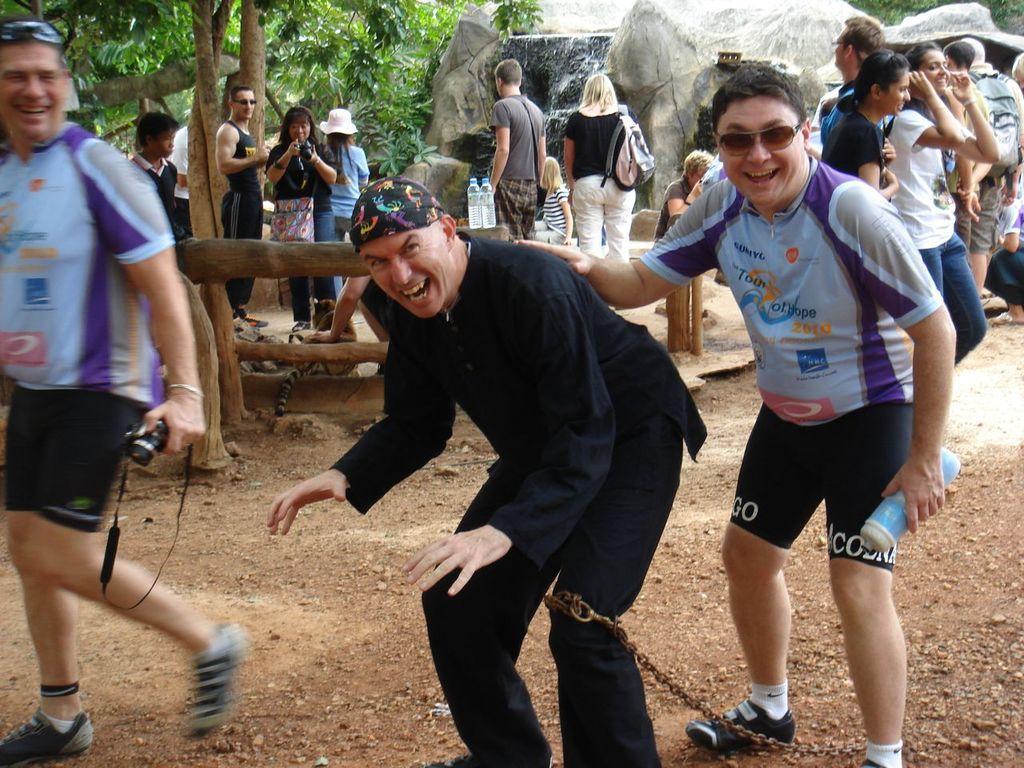Describe this image in one or two sentences. In this image, we can see some people standing, there are some people walking, we can see the rocks, there are some trees and we can see two water bottles. 